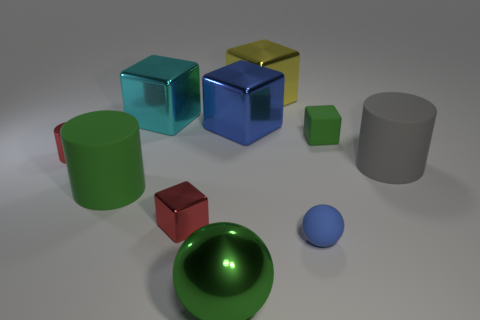Are there an equal number of cylinders to the left of the large cyan metallic object and tiny blocks?
Ensure brevity in your answer.  Yes. What size is the green metal object that is the same shape as the blue matte thing?
Provide a short and direct response. Large. There is a small green rubber object; does it have the same shape as the green matte thing left of the big shiny ball?
Your answer should be compact. No. There is a gray rubber cylinder that is right of the green matte thing to the left of the large green metallic sphere; what size is it?
Provide a short and direct response. Large. Are there an equal number of big rubber things on the right side of the large green cylinder and large green objects that are on the left side of the big cyan metallic thing?
Offer a very short reply. Yes. What is the color of the other large rubber thing that is the same shape as the gray matte object?
Offer a very short reply. Green. How many small matte objects have the same color as the matte sphere?
Give a very brief answer. 0. There is a blue thing that is in front of the tiny green rubber object; is its shape the same as the big cyan shiny object?
Offer a very short reply. No. There is a red object behind the small red shiny object on the right side of the tiny red object behind the tiny red metallic cube; what shape is it?
Keep it short and to the point. Cylinder. What size is the red cube?
Offer a terse response. Small. 